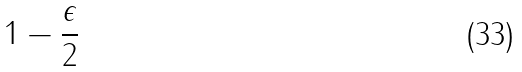Convert formula to latex. <formula><loc_0><loc_0><loc_500><loc_500>1 - { \frac { \epsilon } { 2 } }</formula> 